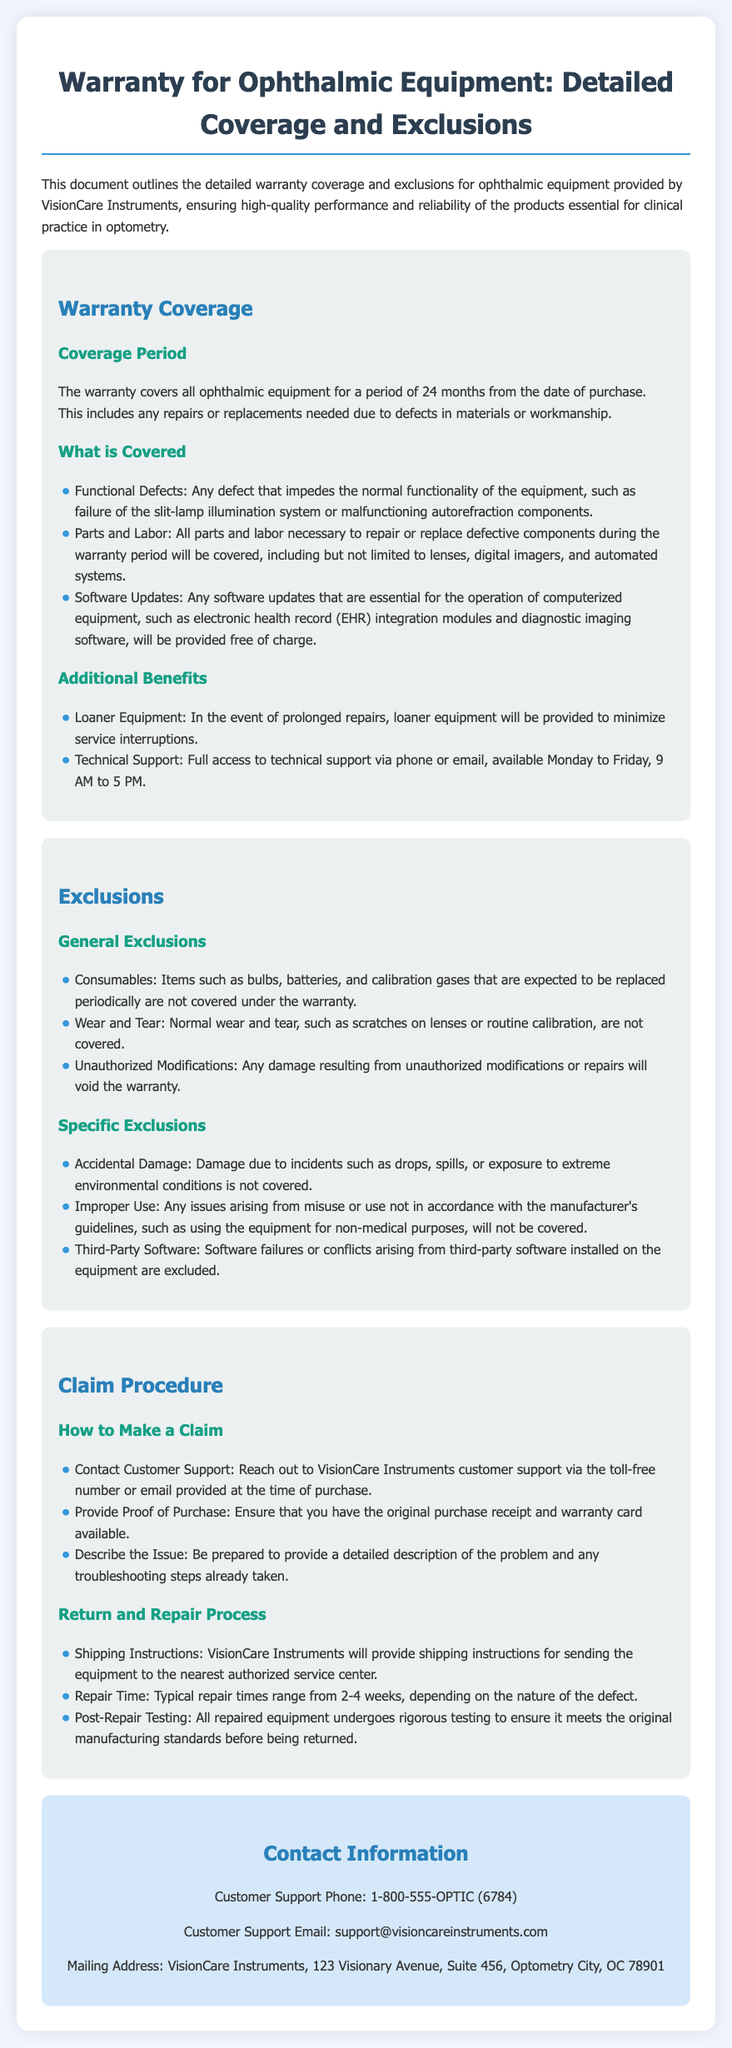What is the warranty coverage period? The warranty covers all ophthalmic equipment for a period of 24 months from the date of purchase.
Answer: 24 months What types of defects are covered under the warranty? The document specifies that functional defects such as malfunctioning components are covered.
Answer: Functional Defects Are software updates included in the warranty? The document states that software updates necessary for operation will be provided free of charge.
Answer: Yes What items are excluded from the warranty? The document lists consumables like bulbs, batteries, and calibration gases as excluded.
Answer: Consumables How should a claim be initiated? The warranty outlines that a claim begins by contacting customer support.
Answer: Contact Customer Support What is the typical repair time mentioned? The document notes that typical repair times range from 2-4 weeks.
Answer: 2-4 weeks Is accidental damage covered by the warranty? The document clearly states that accidental damage is not covered under the warranty.
Answer: No What benefits are provided during equipment repair? The warranty mentions that loaner equipment will be provided during prolonged repairs.
Answer: Loaner Equipment Where can customer support be contacted? The document provides a toll-free number and email for customer support.
Answer: 1-800-555-OPTIC (6784) and support@visioncareinstruments.com 